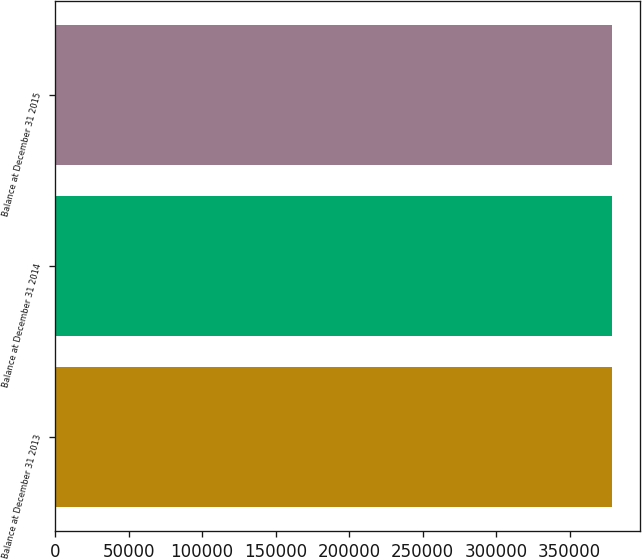Convert chart to OTSL. <chart><loc_0><loc_0><loc_500><loc_500><bar_chart><fcel>Balance at December 31 2013<fcel>Balance at December 31 2014<fcel>Balance at December 31 2015<nl><fcel>379024<fcel>379024<fcel>379024<nl></chart> 